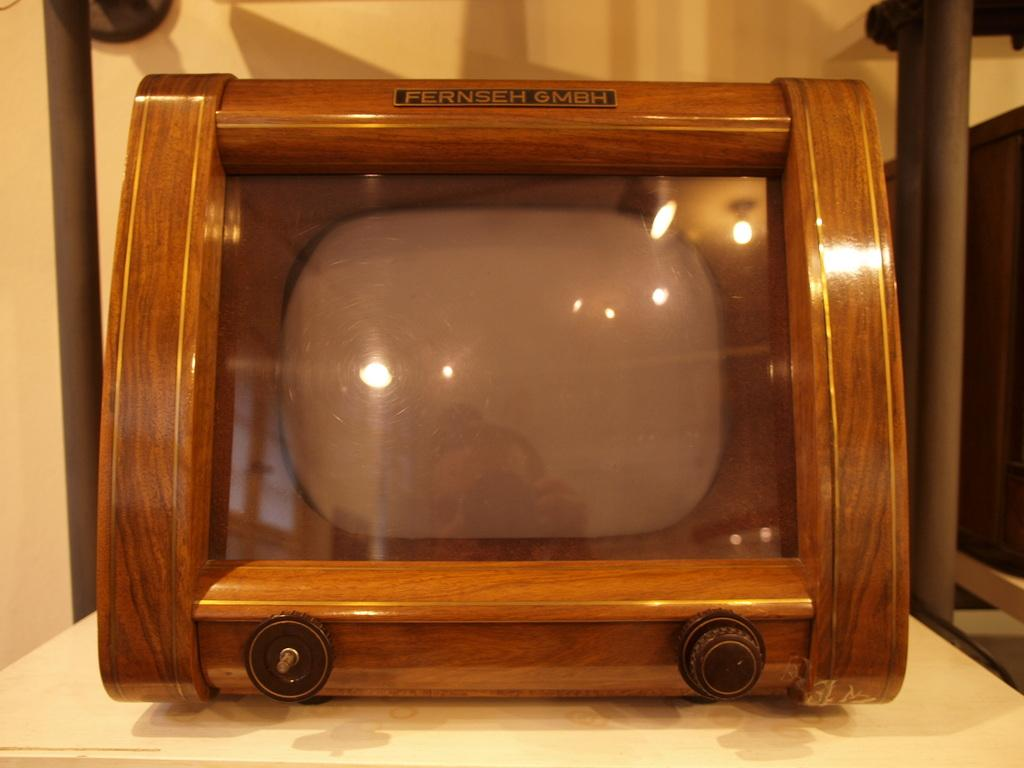<image>
Share a concise interpretation of the image provided. A monitor, called a Fernseh GMBH, has a wooden frame. 